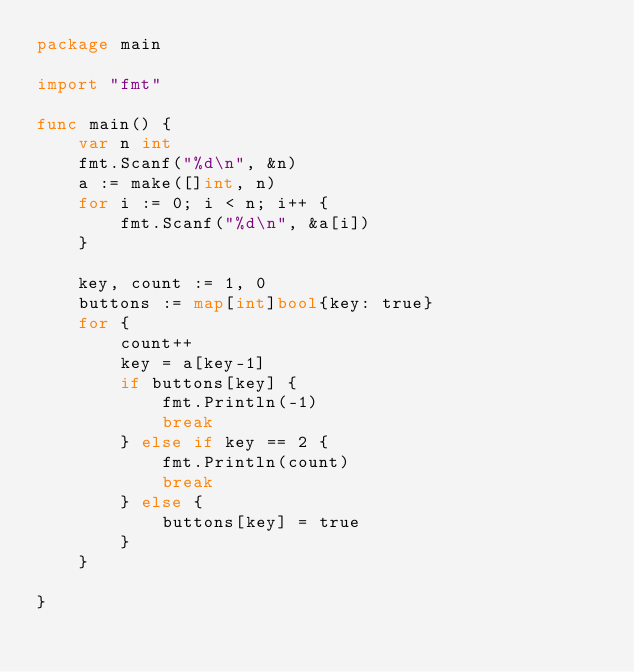<code> <loc_0><loc_0><loc_500><loc_500><_Go_>package main

import "fmt"

func main() {
	var n int
	fmt.Scanf("%d\n", &n)
	a := make([]int, n)
	for i := 0; i < n; i++ {
		fmt.Scanf("%d\n", &a[i])
	}

	key, count := 1, 0
	buttons := map[int]bool{key: true}
	for {
		count++
		key = a[key-1]
		if buttons[key] {
			fmt.Println(-1)
			break
		} else if key == 2 {
			fmt.Println(count)
			break
		} else {
			buttons[key] = true
		}
	}

}
</code> 